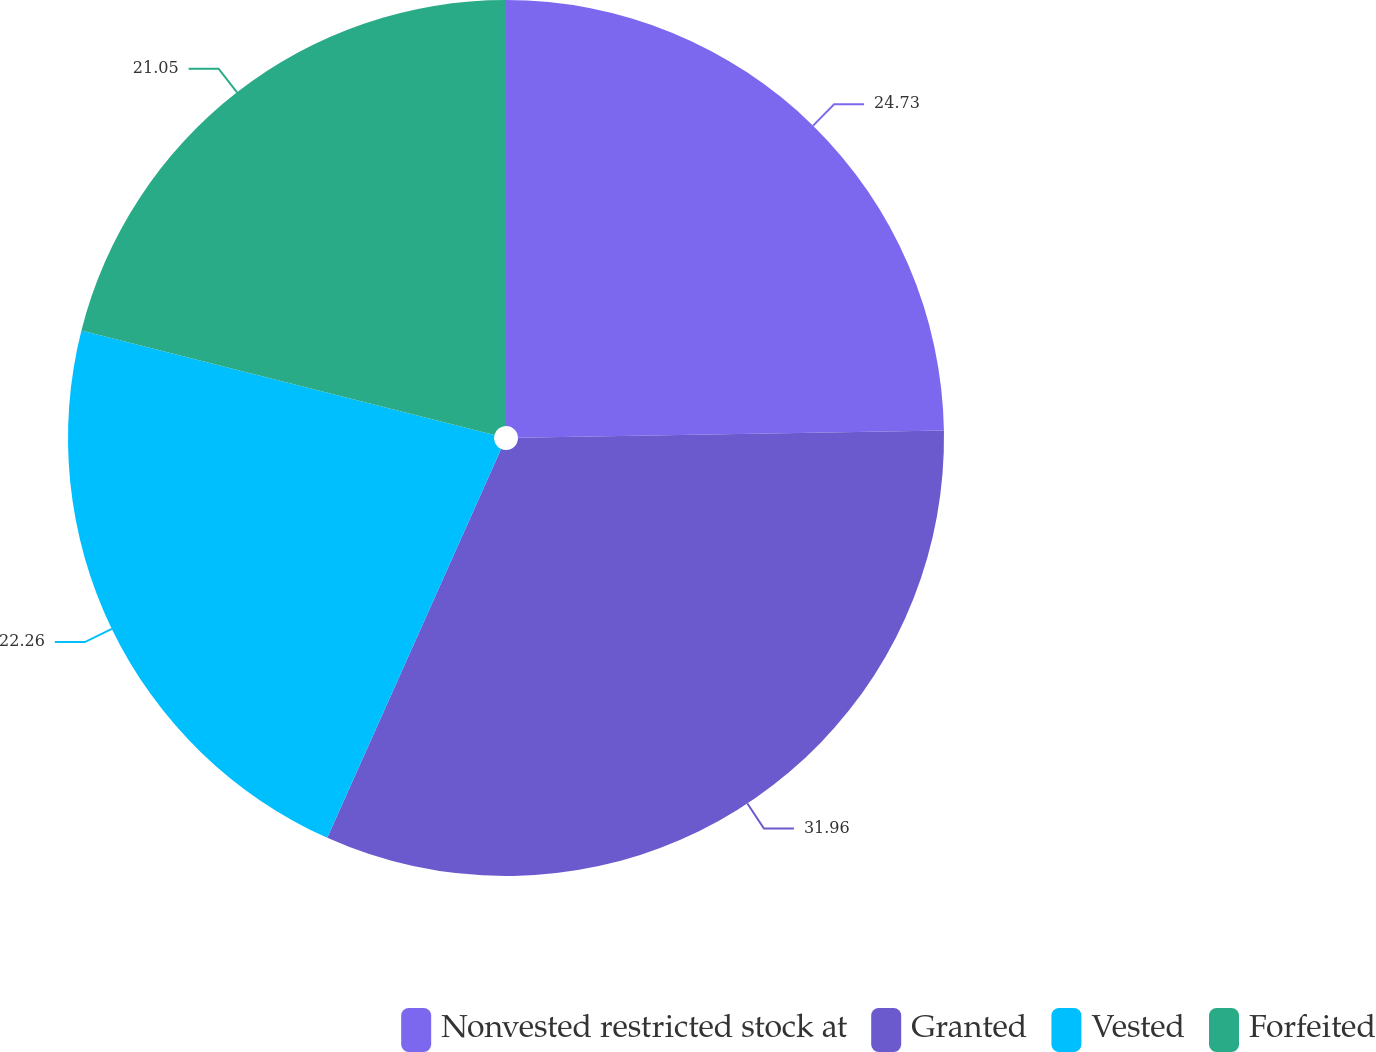Convert chart to OTSL. <chart><loc_0><loc_0><loc_500><loc_500><pie_chart><fcel>Nonvested restricted stock at<fcel>Granted<fcel>Vested<fcel>Forfeited<nl><fcel>24.73%<fcel>31.96%<fcel>22.26%<fcel>21.05%<nl></chart> 